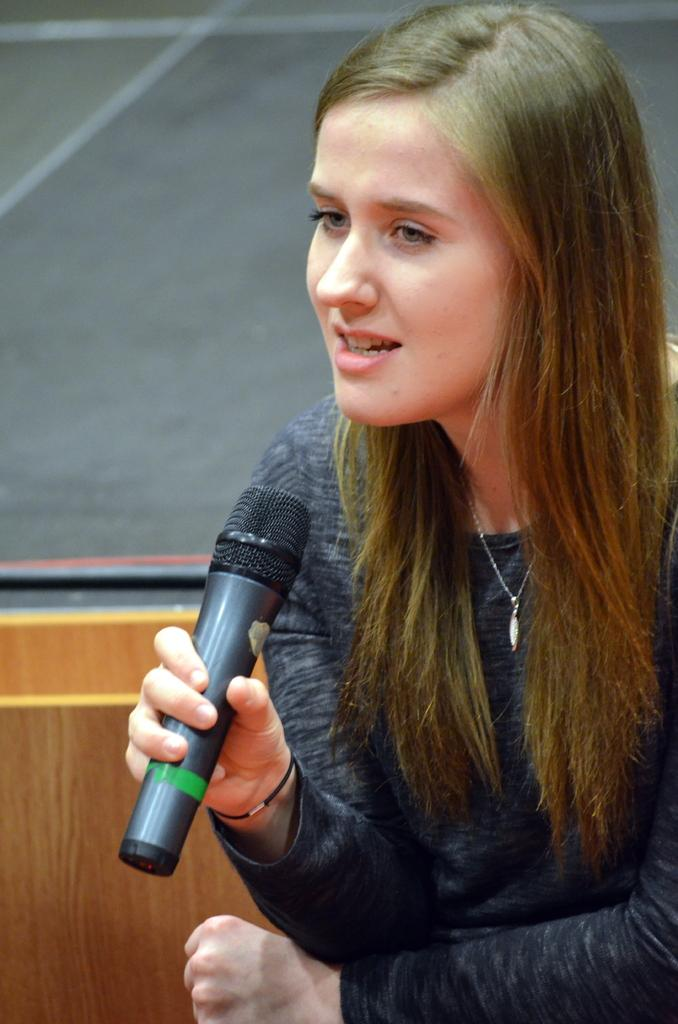Who is the main subject in the image? There is a woman in the image. What is the woman holding in the image? The woman is holding a microphone. What is the woman doing in the image? The woman is talking. What type of hammer is the woman using to fix the bomb in the image? There is no hammer, bomb, or any fixing activity present in the image. The woman is simply holding a microphone and talking. 